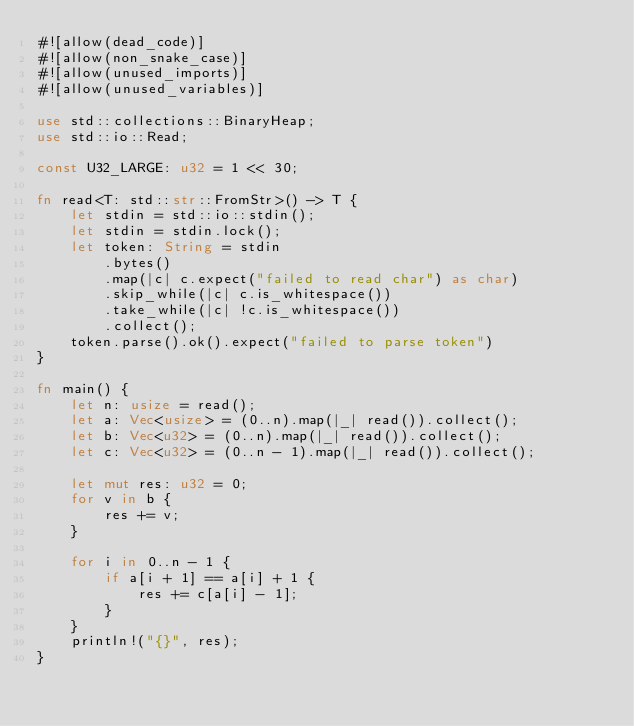<code> <loc_0><loc_0><loc_500><loc_500><_Rust_>#![allow(dead_code)]
#![allow(non_snake_case)]
#![allow(unused_imports)]
#![allow(unused_variables)]

use std::collections::BinaryHeap;
use std::io::Read;

const U32_LARGE: u32 = 1 << 30;

fn read<T: std::str::FromStr>() -> T {
    let stdin = std::io::stdin();
    let stdin = stdin.lock();
    let token: String = stdin
        .bytes()
        .map(|c| c.expect("failed to read char") as char)
        .skip_while(|c| c.is_whitespace())
        .take_while(|c| !c.is_whitespace())
        .collect();
    token.parse().ok().expect("failed to parse token")
}

fn main() {
    let n: usize = read();
    let a: Vec<usize> = (0..n).map(|_| read()).collect();
    let b: Vec<u32> = (0..n).map(|_| read()).collect();
    let c: Vec<u32> = (0..n - 1).map(|_| read()).collect();

    let mut res: u32 = 0;
    for v in b {
        res += v;
    }

    for i in 0..n - 1 {
        if a[i + 1] == a[i] + 1 {
            res += c[a[i] - 1];
        }
    }
    println!("{}", res);
}
</code> 